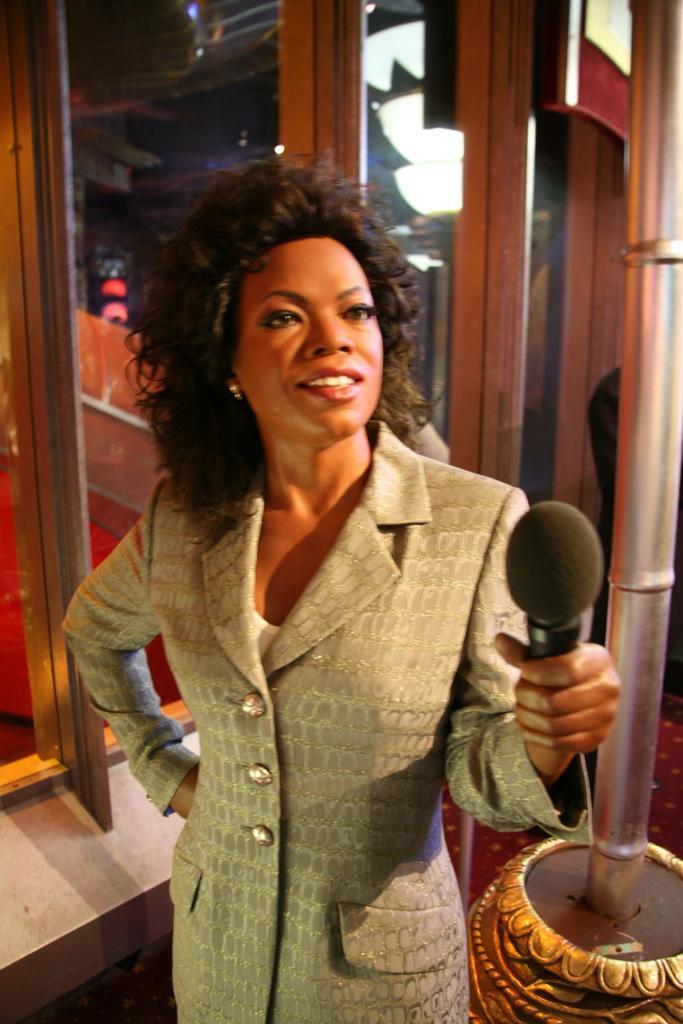Describe this image in one or two sentences. In the image there is a statue of a lady with jacket and holding the mic. Beside the statue there is a pole. Behind the statue there are glass doors. 